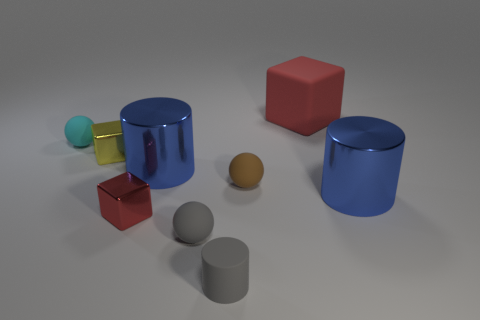Subtract all red blocks. How many were subtracted if there are1red blocks left? 1 Add 1 big blue metallic objects. How many objects exist? 10 Subtract all cubes. How many objects are left? 6 Add 1 tiny gray spheres. How many tiny gray spheres are left? 2 Add 5 small brown rubber things. How many small brown rubber things exist? 6 Subtract 1 yellow cubes. How many objects are left? 8 Subtract all yellow objects. Subtract all tiny gray rubber cylinders. How many objects are left? 7 